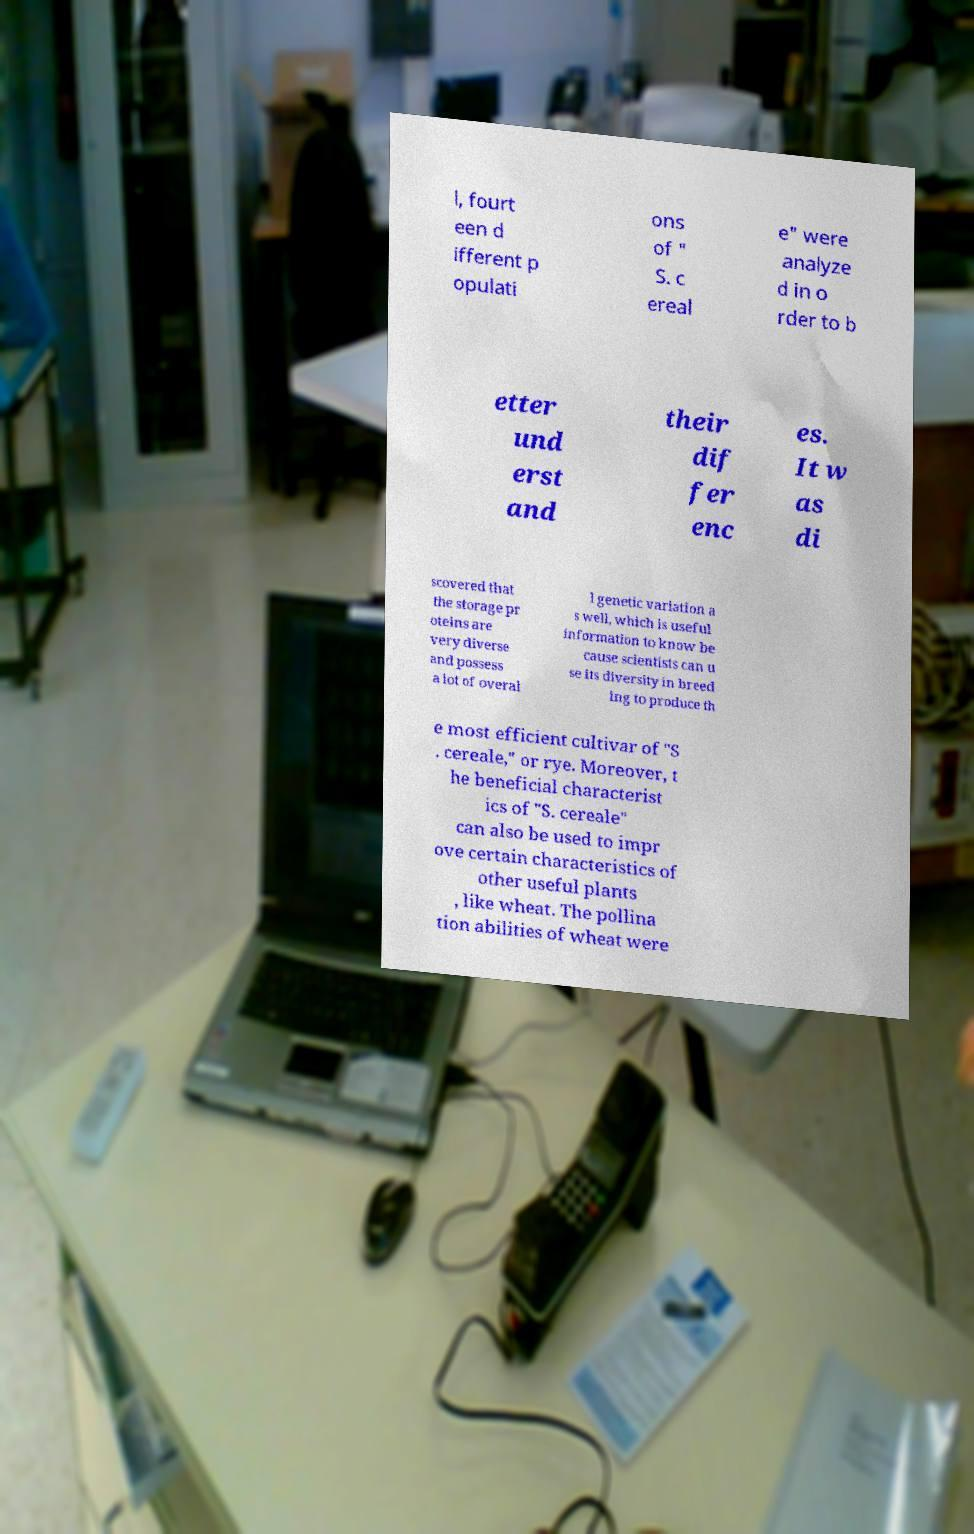Please read and relay the text visible in this image. What does it say? l, fourt een d ifferent p opulati ons of " S. c ereal e" were analyze d in o rder to b etter und erst and their dif fer enc es. It w as di scovered that the storage pr oteins are very diverse and possess a lot of overal l genetic variation a s well, which is useful information to know be cause scientists can u se its diversity in breed ing to produce th e most efficient cultivar of "S . cereale," or rye. Moreover, t he beneficial characterist ics of "S. cereale" can also be used to impr ove certain characteristics of other useful plants , like wheat. The pollina tion abilities of wheat were 